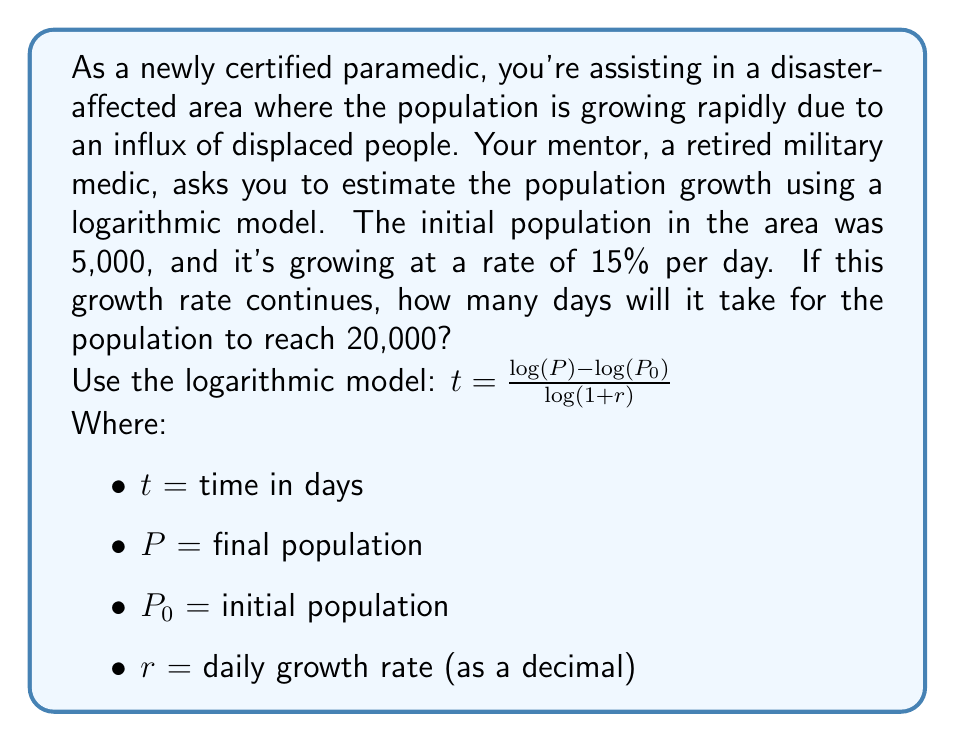Give your solution to this math problem. To solve this problem, we'll use the logarithmic model for population growth:

$t = \frac{\log(P) - \log(P_0)}{\log(1+r)}$

Given:
$P_0 = 5,000$ (initial population)
$P = 20,000$ (final population)
$r = 0.15$ (15% daily growth rate as a decimal)

Let's substitute these values into the equation:

$t = \frac{\log(20,000) - \log(5,000)}{\log(1+0.15)}$

Now, let's solve step-by-step:

1) Simplify the numerator:
   $\log(20,000) - \log(5,000) = \log(\frac{20,000}{5,000}) = \log(4)$

2) Our equation now looks like:
   $t = \frac{\log(4)}{\log(1.15)}$

3) Using a calculator or logarithm tables:
   $\log(4) \approx 0.6020599913$
   $\log(1.15) \approx 0.0607978656$

4) Divide:
   $t = \frac{0.6020599913}{0.0607978656} \approx 9.9026$

5) Since we can't have a fractional day in this context, we round up to the next whole number.

Therefore, it will take 10 days for the population to reach 20,000.
Answer: 10 days 